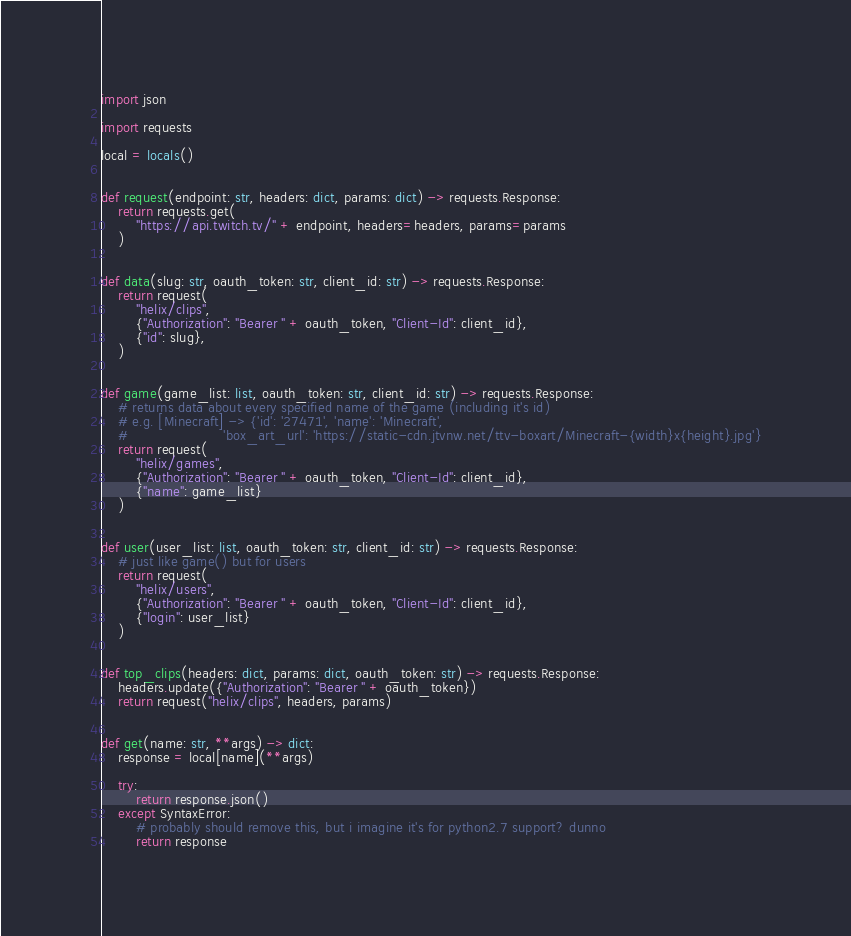Convert code to text. <code><loc_0><loc_0><loc_500><loc_500><_Python_>import json

import requests

local = locals()


def request(endpoint: str, headers: dict, params: dict) -> requests.Response:
    return requests.get(
        "https://api.twitch.tv/" + endpoint, headers=headers, params=params
    )


def data(slug: str, oauth_token: str, client_id: str) -> requests.Response:
    return request(
        "helix/clips",
        {"Authorization": "Bearer " + oauth_token, "Client-Id": client_id},
        {"id": slug},
    )


def game(game_list: list, oauth_token: str, client_id: str) -> requests.Response:
    # returns data about every specified name of the game (including it's id)
    # e.g. [Minecraft] -> {'id': '27471', 'name': 'Minecraft',
    #                      'box_art_url': 'https://static-cdn.jtvnw.net/ttv-boxart/Minecraft-{width}x{height}.jpg'}
    return request(
        "helix/games",
        {"Authorization": "Bearer " + oauth_token, "Client-Id": client_id},
        {"name": game_list}
    )


def user(user_list: list, oauth_token: str, client_id: str) -> requests.Response:
    # just like game() but for users
    return request(
        "helix/users",
        {"Authorization": "Bearer " + oauth_token, "Client-Id": client_id},
        {"login": user_list}
    )


def top_clips(headers: dict, params: dict, oauth_token: str) -> requests.Response:
    headers.update({"Authorization": "Bearer " + oauth_token})
    return request("helix/clips", headers, params)


def get(name: str, **args) -> dict:
    response = local[name](**args)

    try:
        return response.json()
    except SyntaxError:
        # probably should remove this, but i imagine it's for python2.7 support? dunno
        return response
</code> 